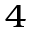Convert formula to latex. <formula><loc_0><loc_0><loc_500><loc_500>_ { 4 }</formula> 